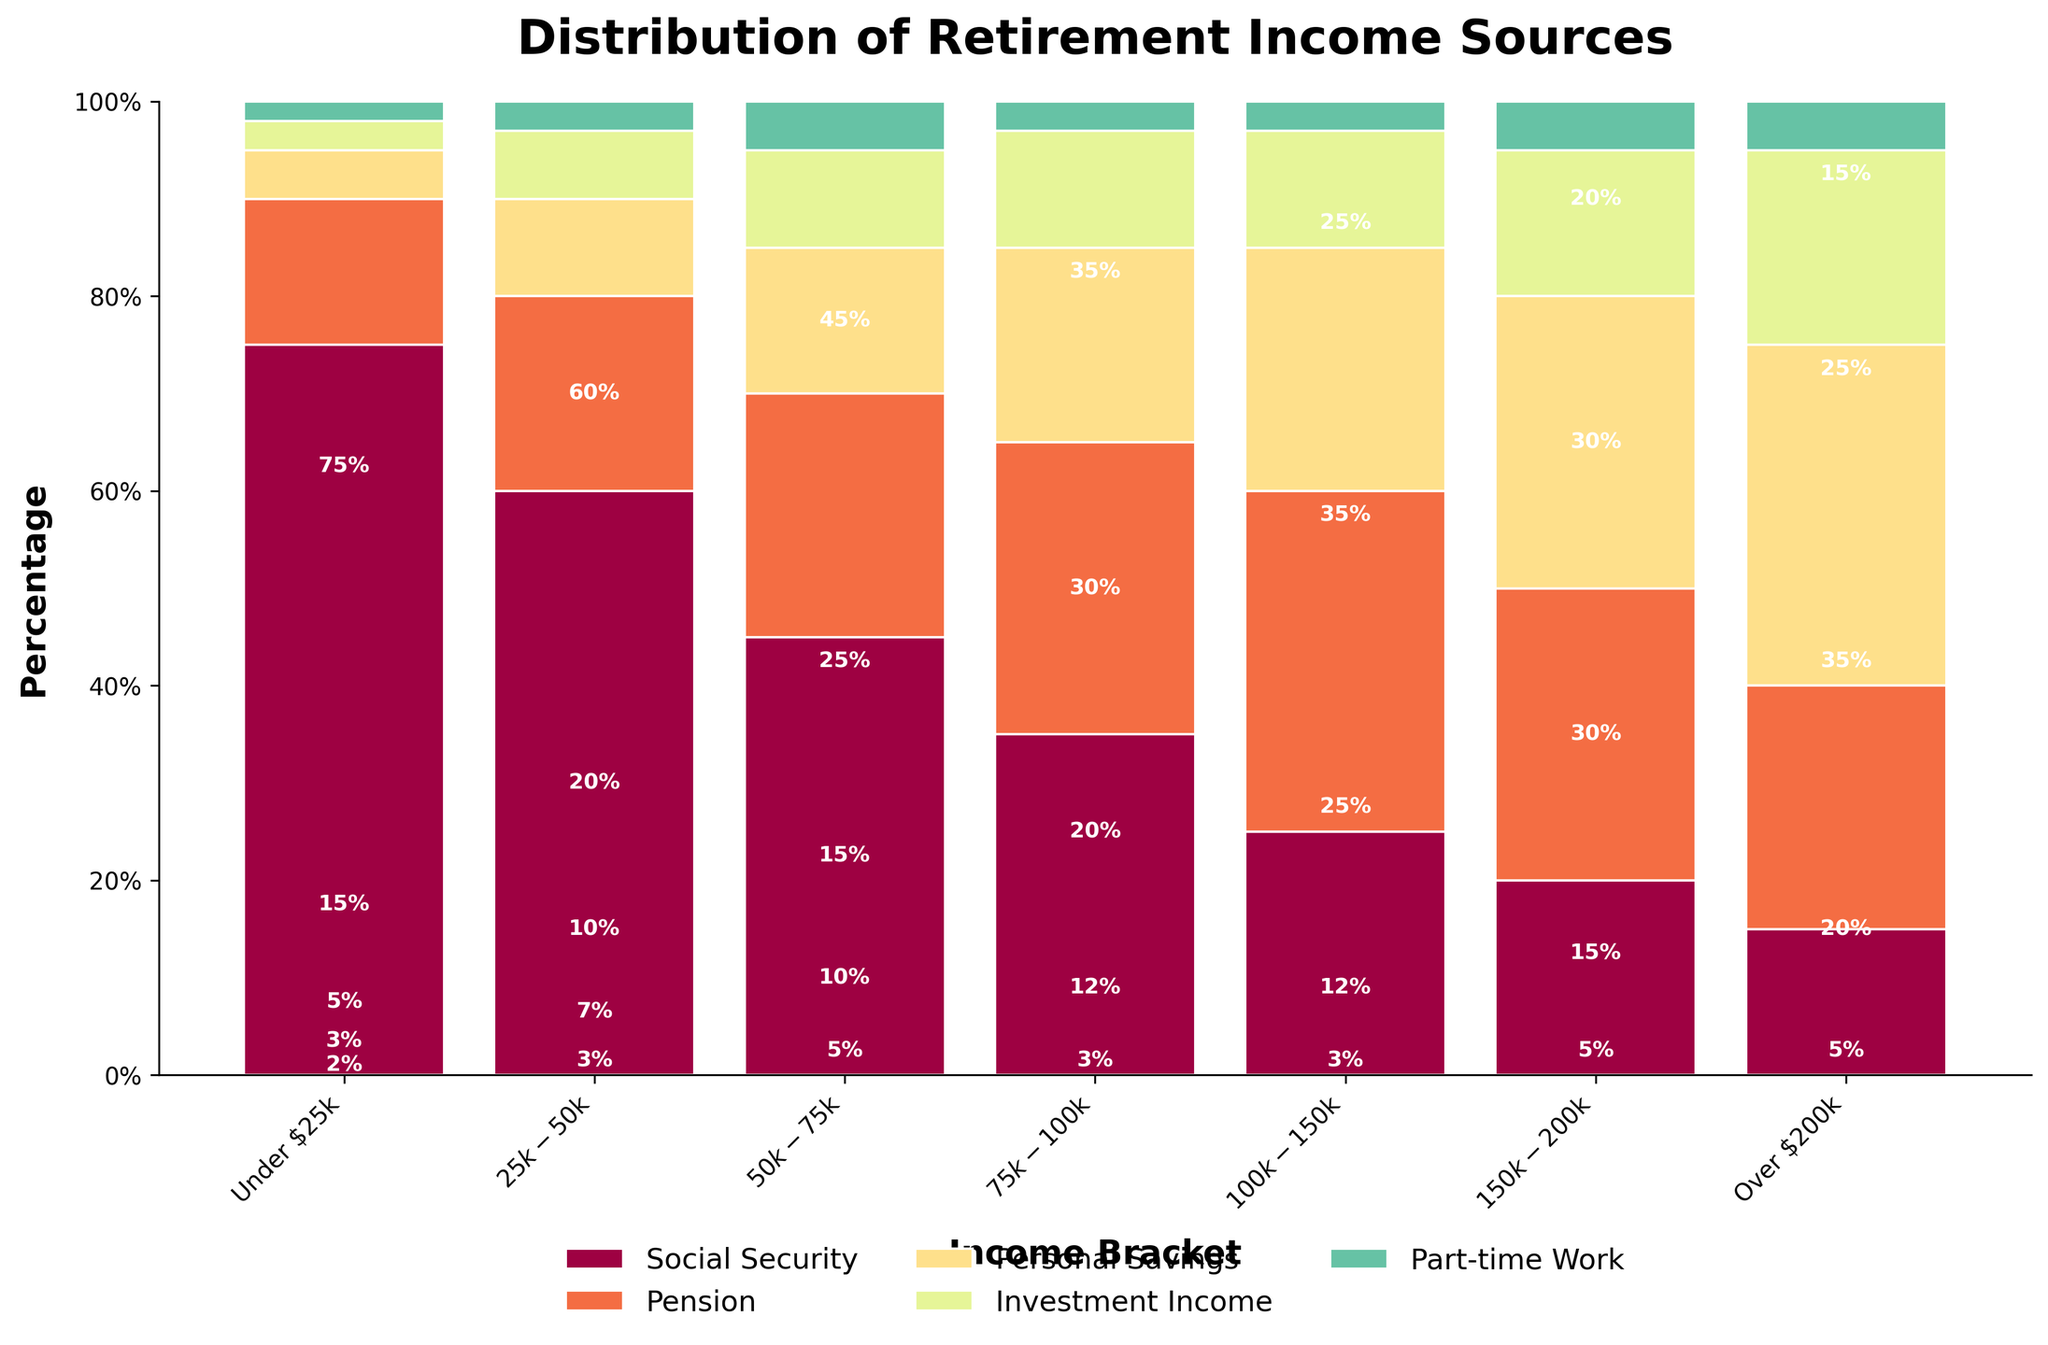What income bracket relies most heavily on Social Security for their retirement income? By observing the figure, the income bracket with the tallest bar segment for Social Security (often colored differently such as blue) indicates the bracket that relies most heavily on it. The "Under $25k" bracket shows the largest portion with 75%.
Answer: Under $25k Which income bracket has the highest percentage coming from personal savings? Look at the bar segments for "Personal Savings" across all income brackets and find the tallest one. The "Over $200k" bracket has the tallest segment for personal savings at 35%.
Answer: Over $200k How does the percentage of income from pensions compare between the $50k-$75k and the $100k-$150k brackets? Compare the heights of the pension bar segments for these two brackets. The $50k-$75k bracket has 25% and the $100k-$150k bracket has 35%. The $100k-$150k bracket relies more on pensions.
Answer: $100k-$150k relies more What's the combined percentage of investment income and part-time work for the $150k-$200k income bracket? Sum the percentages of investment income and part-time work for the $150k-$200k bracket. 15% (investment income) + 5% (part-time work) = 20%.
Answer: 20% Which income bracket is the least dependent on Social Security? Find the income bracket with the smallest segment for Social Security. The "Over $200k" bracket has the smallest Social Security segment at 15%.
Answer: Over $200k What is the difference in the percentage contribution of personal savings between the $25k-$50k and the $75k-$100k brackets? Subtract the personal savings percentage of the $25k-$50k bracket from that of the $75k-$100k bracket. 20% - 10% = 10%.
Answer: 10% Which two income sources have the largest combined contribution in the $75k-$100k bracket? Observe the two tallest segments in the $75k-$100k bracket and sum their percentages. Pension (30%) + Personal Savings (20%) = 50%.
Answer: Pension and Personal Savings How much more does the highest income bracket get from investment income compared to the lowest income bracket? Subtract the percentage of investment income in the Under $25k bracket from that in the Over $200k bracket. 20% - 3% = 17%.
Answer: 17% What can you say about the role of part-time work in retirement income across different income brackets? Compare the part-time work segments across all brackets. Part-time work generally contributes a consistent but small portion (2-5%) across all brackets, with slightly higher values in middle and higher brackets (5%).
Answer: Small and consistent What sources make up exactly half of the retirement income for the $100k-$150k bracket? Look for combinations of sources that sum to 50% for the $100k-$150k bracket. Social Security (25%) + Pension (35%) = 60%, but Social Security (25%) + Investment Income (12%) + Part-time Work (3%) = 40% doesn't work. Hence, none pair up exactly to make 50%.
Answer: None 